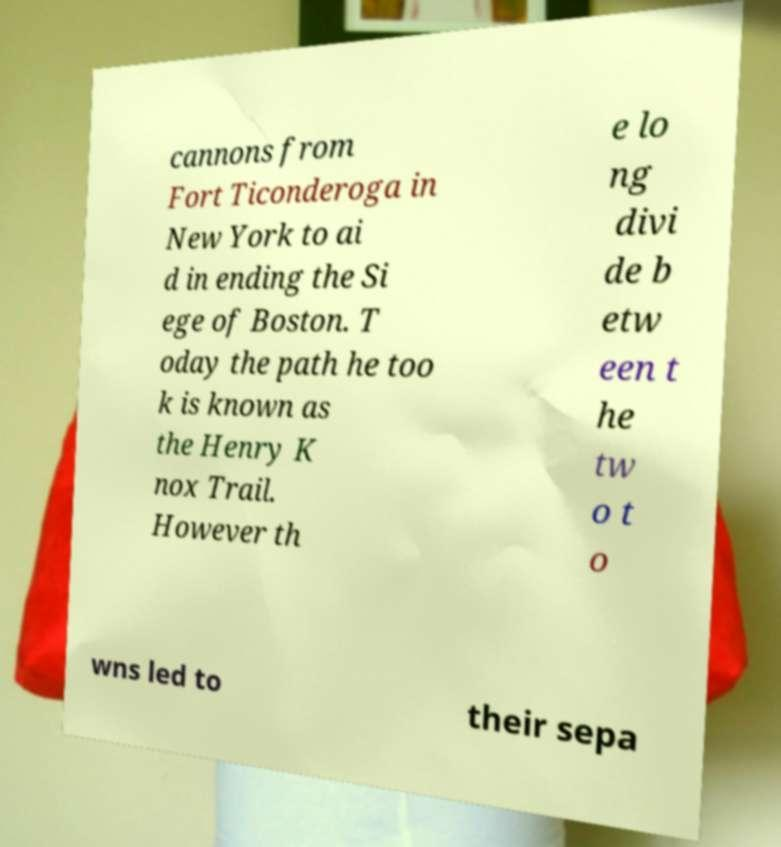Can you read and provide the text displayed in the image?This photo seems to have some interesting text. Can you extract and type it out for me? cannons from Fort Ticonderoga in New York to ai d in ending the Si ege of Boston. T oday the path he too k is known as the Henry K nox Trail. However th e lo ng divi de b etw een t he tw o t o wns led to their sepa 